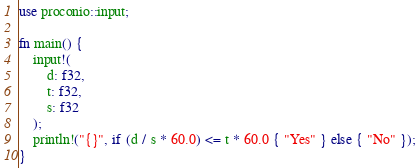<code> <loc_0><loc_0><loc_500><loc_500><_Rust_>use proconio::input;

fn main() {
    input!(
        d: f32,
        t: f32,
        s: f32
    );
    println!("{}", if (d / s * 60.0) <= t * 60.0 { "Yes" } else { "No" });
}</code> 